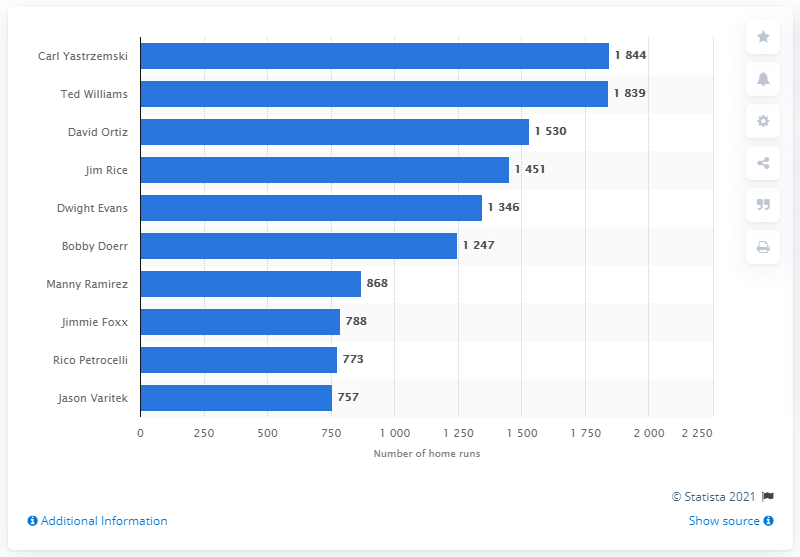Mention a couple of crucial points in this snapshot. The Boston Red Sox franchise record for most RBI belongs to Carl Yastrzemski with the highest total of RBI. 